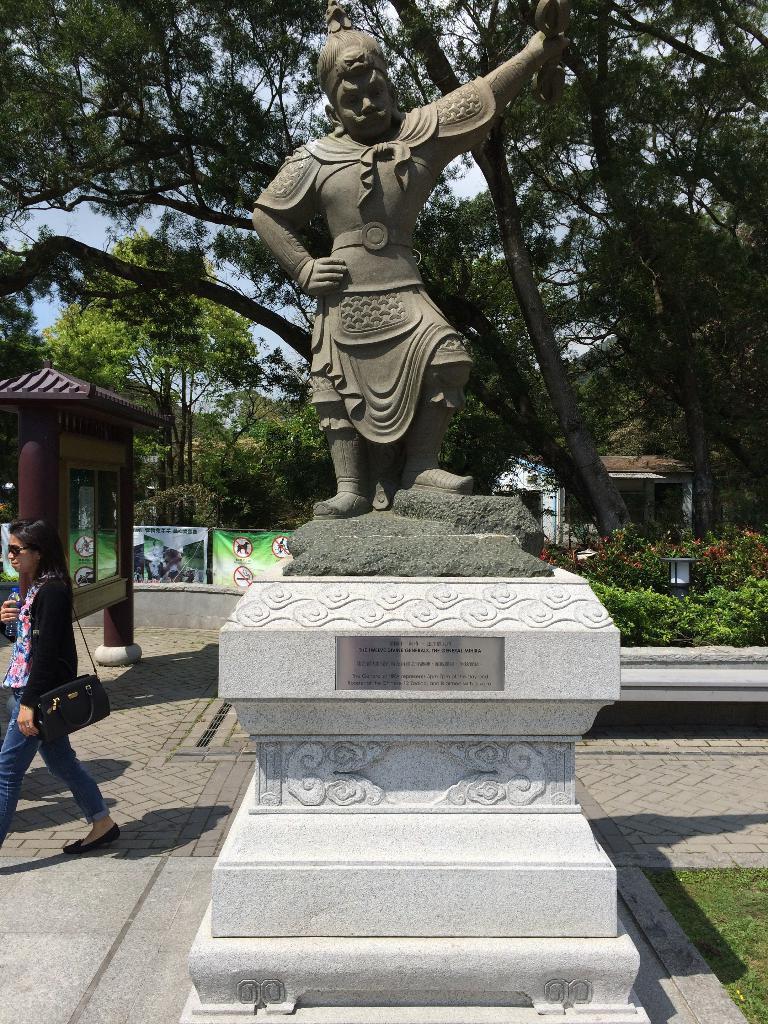Could you give a brief overview of what you see in this image? In this image, we can see some trees and plants. There is a statue in the middle of the image. There is a person and shelter on the left side of the image. There is a banner on the wall. 